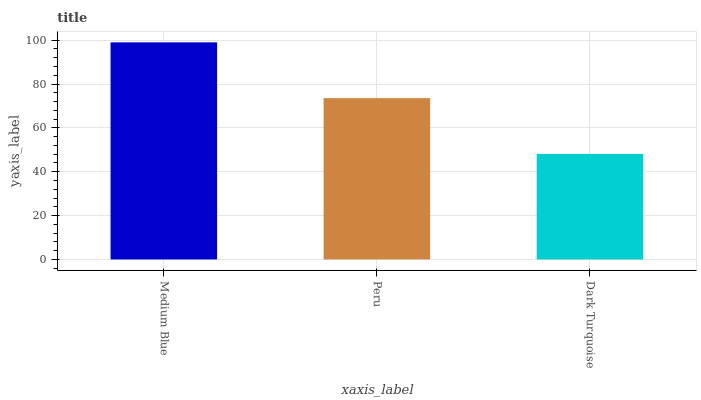Is Peru the minimum?
Answer yes or no. No. Is Peru the maximum?
Answer yes or no. No. Is Medium Blue greater than Peru?
Answer yes or no. Yes. Is Peru less than Medium Blue?
Answer yes or no. Yes. Is Peru greater than Medium Blue?
Answer yes or no. No. Is Medium Blue less than Peru?
Answer yes or no. No. Is Peru the high median?
Answer yes or no. Yes. Is Peru the low median?
Answer yes or no. Yes. Is Dark Turquoise the high median?
Answer yes or no. No. Is Medium Blue the low median?
Answer yes or no. No. 